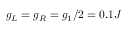<formula> <loc_0><loc_0><loc_500><loc_500>g _ { L } = g _ { R } = g _ { 1 } / 2 = 0 . 1 J</formula> 